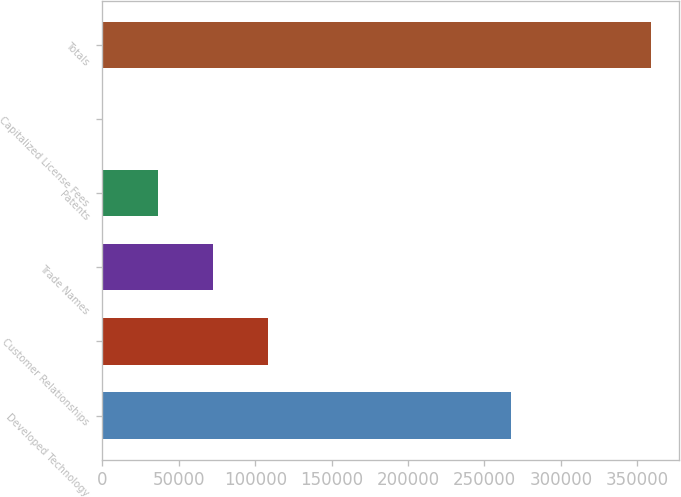<chart> <loc_0><loc_0><loc_500><loc_500><bar_chart><fcel>Developed Technology<fcel>Customer Relationships<fcel>Trade Names<fcel>Patents<fcel>Capitalized License Fees<fcel>Totals<nl><fcel>267259<fcel>108103<fcel>72241.6<fcel>36379.8<fcel>518<fcel>359136<nl></chart> 